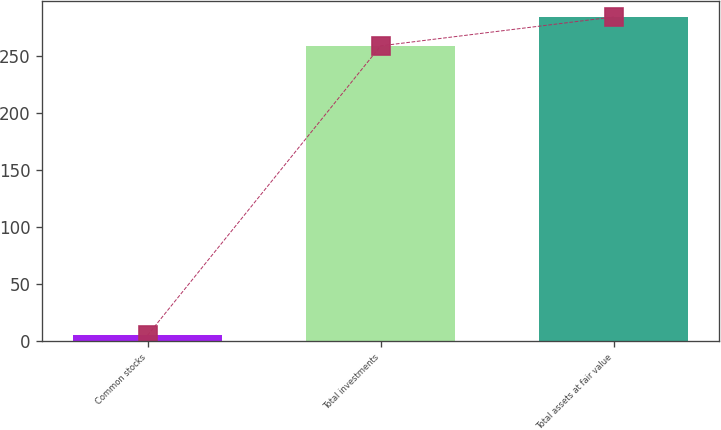Convert chart to OTSL. <chart><loc_0><loc_0><loc_500><loc_500><bar_chart><fcel>Common stocks<fcel>Total investments<fcel>Total assets at fair value<nl><fcel>5<fcel>259<fcel>284.4<nl></chart> 